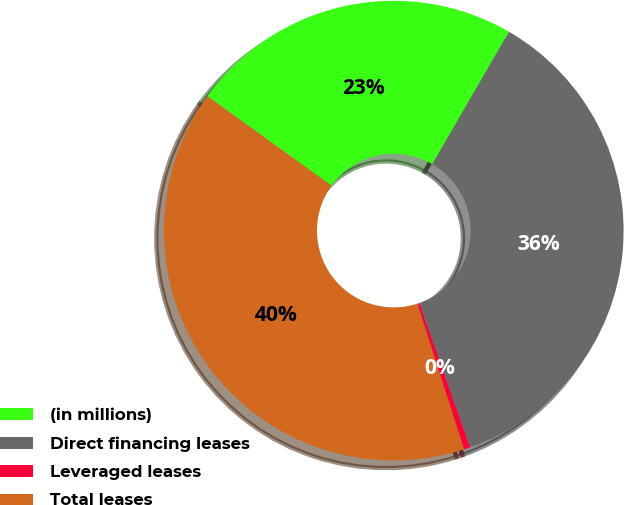Convert chart. <chart><loc_0><loc_0><loc_500><loc_500><pie_chart><fcel>(in millions)<fcel>Direct financing leases<fcel>Leveraged leases<fcel>Total leases<nl><fcel>23.42%<fcel>36.25%<fcel>0.45%<fcel>39.88%<nl></chart> 